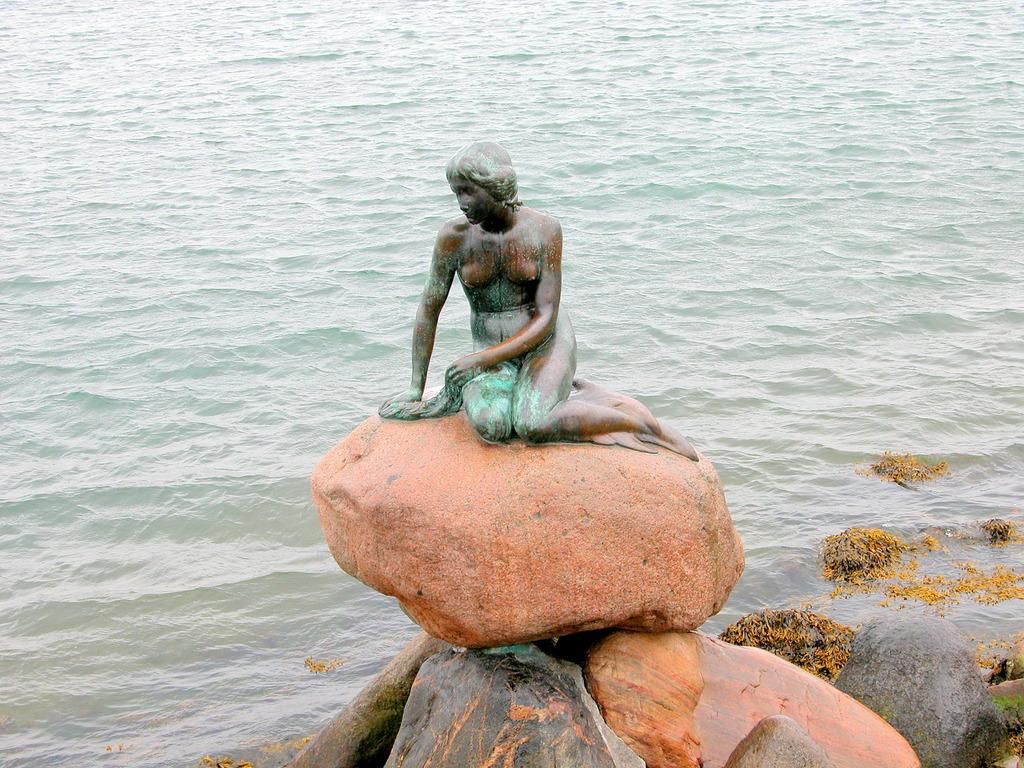What is the main subject in the center of the image? There is a sculpture in the center of the image. What can be seen at the bottom of the image? There are rocks at the bottom of the image. What is visible in the background of the image? There is water visible in the background of the image. Can you tell me which actor is touching the sculpture in the image? There is no actor present in the image, and therefore no one is touching the sculpture. 